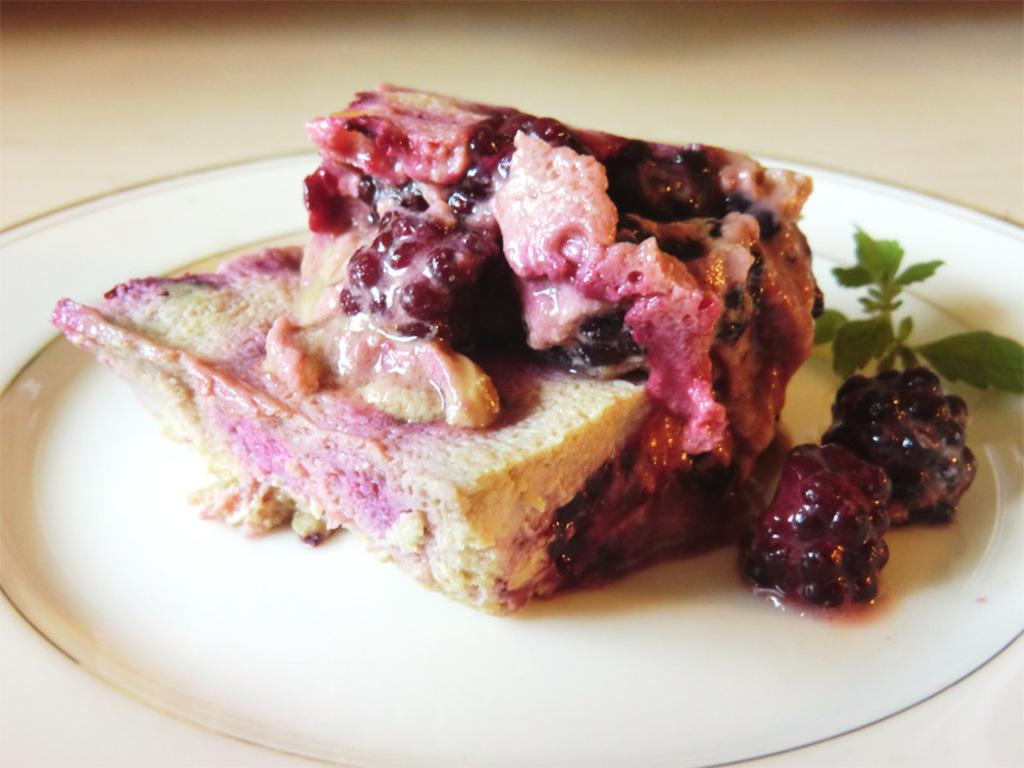What is on the plate that is visible in the image? The plate contains food items. Can you identify any specific food items on the plate? Yes, there are two blueberries on the plate. What else is present on the plate besides the food items? There are leaves on the plate. On what surface is the plate placed in the image? The plate is placed on a white surface. What is the price of the furniture in the image? There is no furniture present in the image, so it is not possible to determine the price of any furniture. 